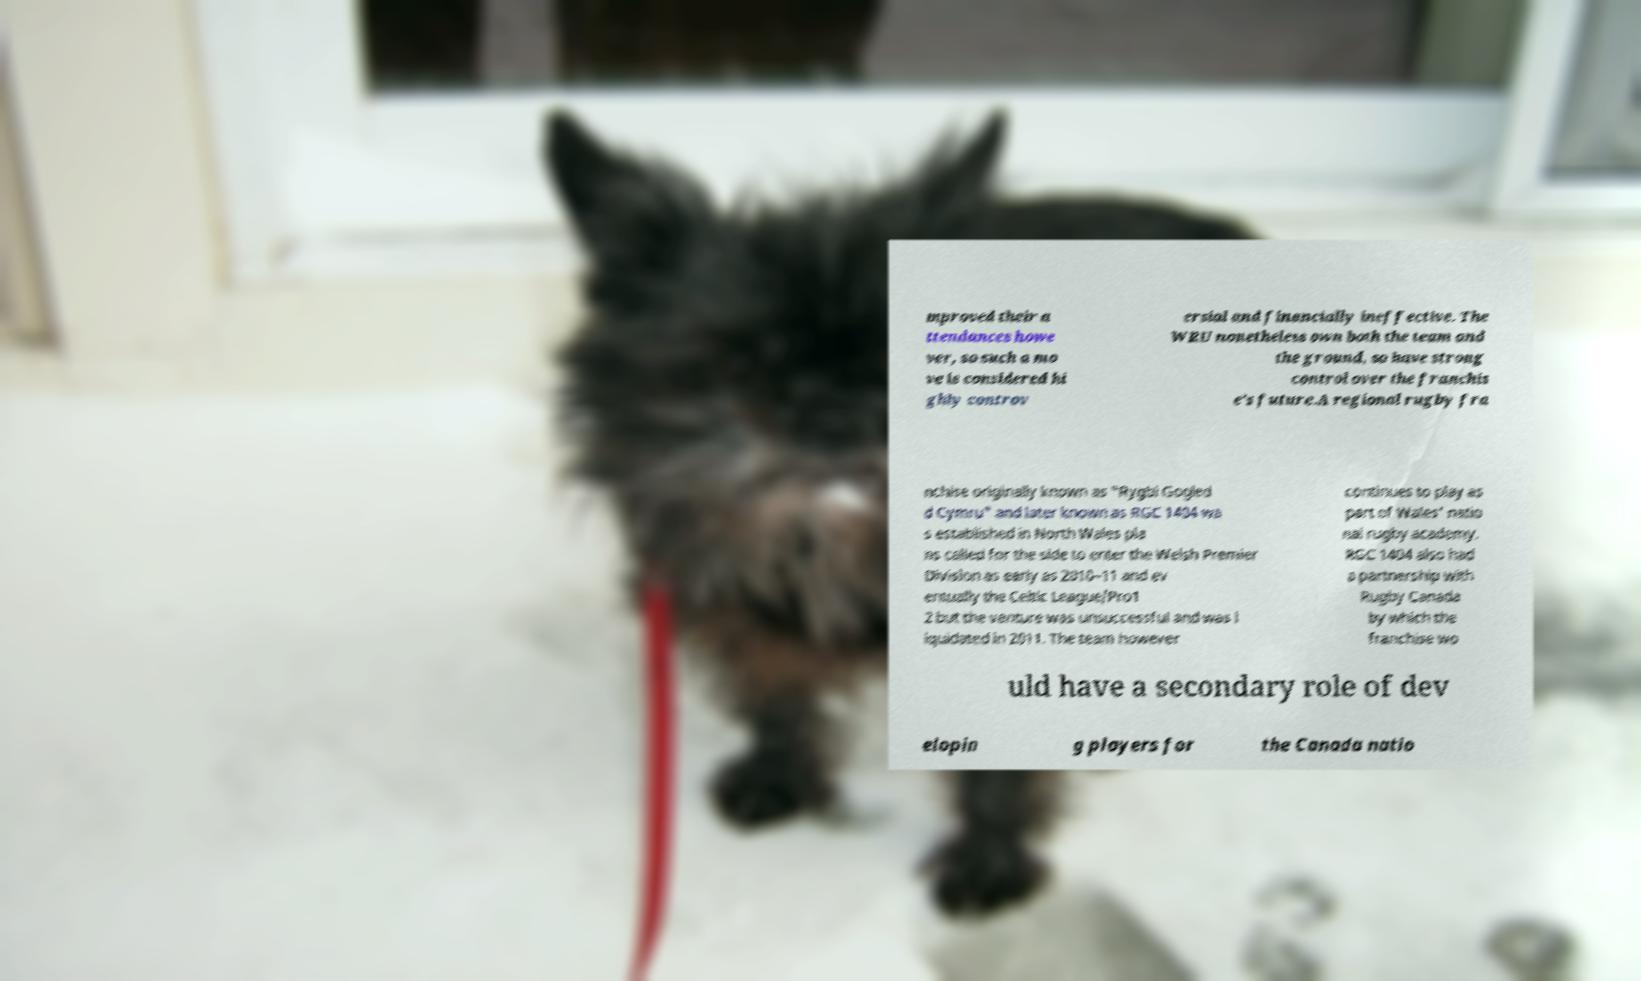Could you assist in decoding the text presented in this image and type it out clearly? mproved their a ttendances howe ver, so such a mo ve is considered hi ghly controv ersial and financially ineffective. The WRU nonetheless own both the team and the ground, so have strong control over the franchis e's future.A regional rugby fra nchise originally known as "Rygbi Gogled d Cymru" and later known as RGC 1404 wa s established in North Wales pla ns called for the side to enter the Welsh Premier Division as early as 2010–11 and ev entually the Celtic League/Pro1 2 but the venture was unsuccessful and was l iquidated in 2011. The team however continues to play as part of Wales' natio nal rugby academy. RGC 1404 also had a partnership with Rugby Canada by which the franchise wo uld have a secondary role of dev elopin g players for the Canada natio 